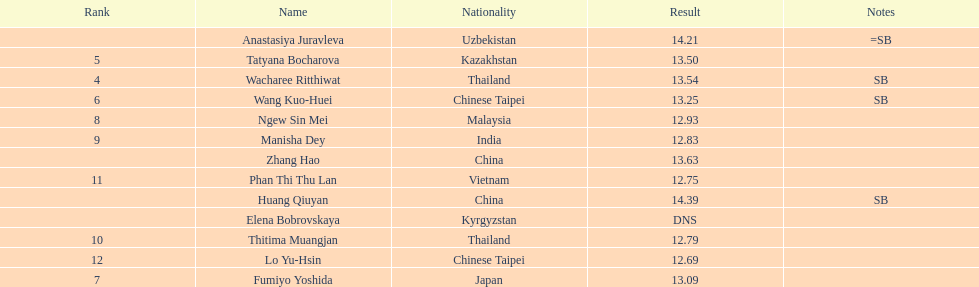Which country came in first? China. 